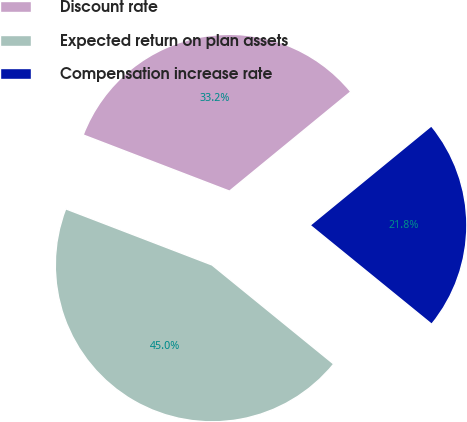<chart> <loc_0><loc_0><loc_500><loc_500><pie_chart><fcel>Discount rate<fcel>Expected return on plan assets<fcel>Compensation increase rate<nl><fcel>33.24%<fcel>44.96%<fcel>21.8%<nl></chart> 